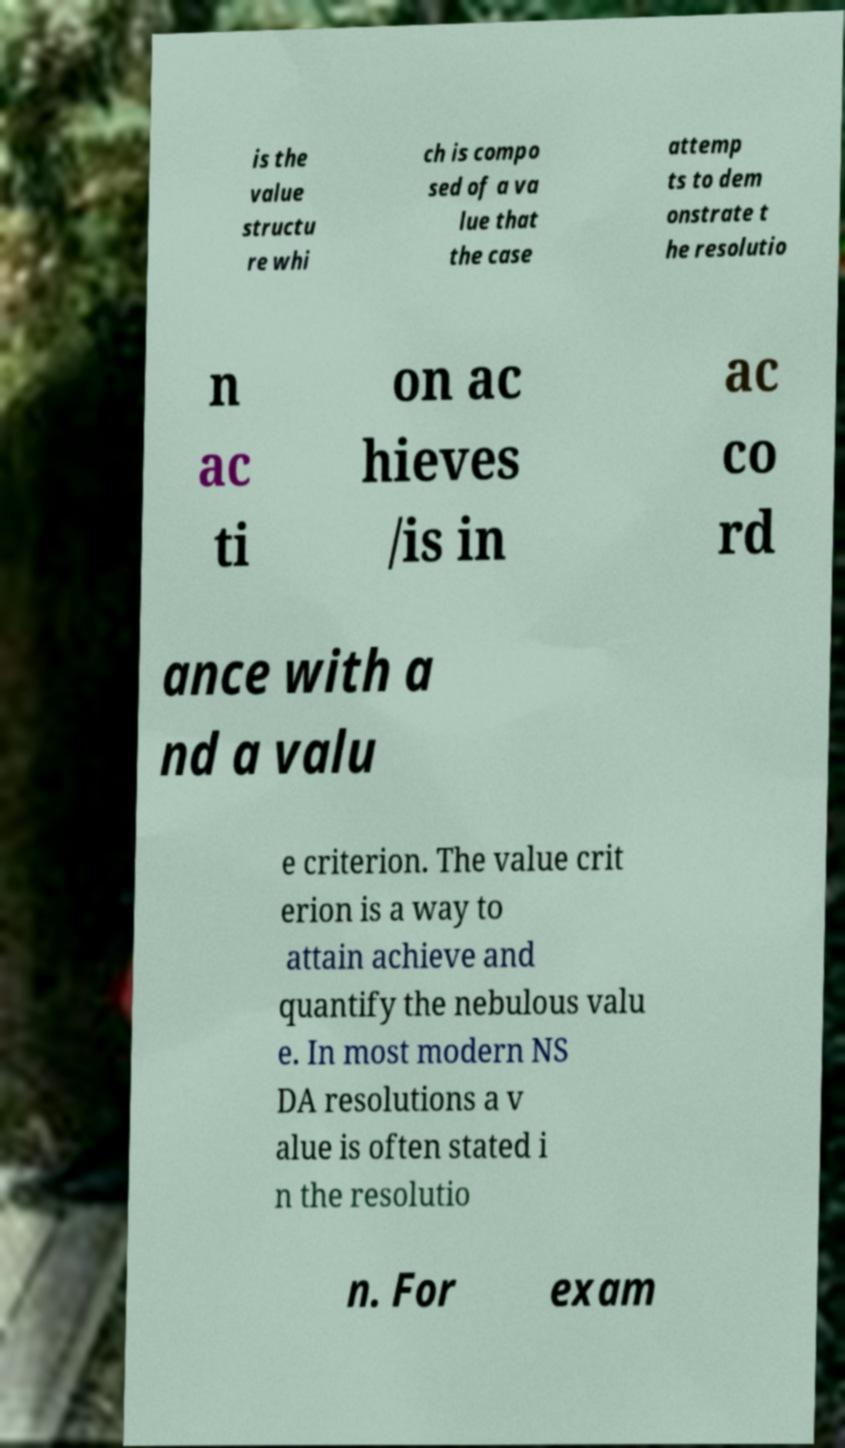Please identify and transcribe the text found in this image. is the value structu re whi ch is compo sed of a va lue that the case attemp ts to dem onstrate t he resolutio n ac ti on ac hieves /is in ac co rd ance with a nd a valu e criterion. The value crit erion is a way to attain achieve and quantify the nebulous valu e. In most modern NS DA resolutions a v alue is often stated i n the resolutio n. For exam 